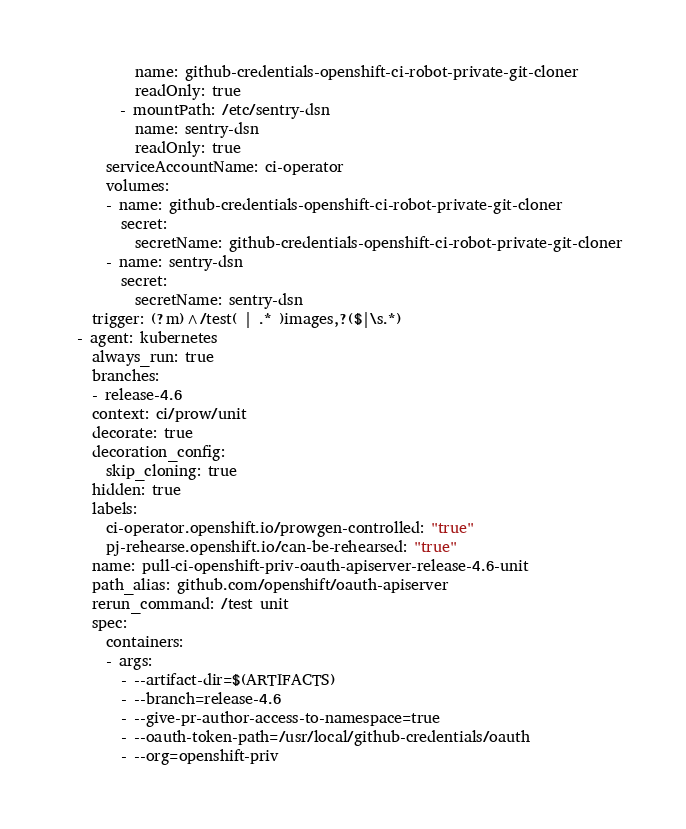<code> <loc_0><loc_0><loc_500><loc_500><_YAML_>          name: github-credentials-openshift-ci-robot-private-git-cloner
          readOnly: true
        - mountPath: /etc/sentry-dsn
          name: sentry-dsn
          readOnly: true
      serviceAccountName: ci-operator
      volumes:
      - name: github-credentials-openshift-ci-robot-private-git-cloner
        secret:
          secretName: github-credentials-openshift-ci-robot-private-git-cloner
      - name: sentry-dsn
        secret:
          secretName: sentry-dsn
    trigger: (?m)^/test( | .* )images,?($|\s.*)
  - agent: kubernetes
    always_run: true
    branches:
    - release-4.6
    context: ci/prow/unit
    decorate: true
    decoration_config:
      skip_cloning: true
    hidden: true
    labels:
      ci-operator.openshift.io/prowgen-controlled: "true"
      pj-rehearse.openshift.io/can-be-rehearsed: "true"
    name: pull-ci-openshift-priv-oauth-apiserver-release-4.6-unit
    path_alias: github.com/openshift/oauth-apiserver
    rerun_command: /test unit
    spec:
      containers:
      - args:
        - --artifact-dir=$(ARTIFACTS)
        - --branch=release-4.6
        - --give-pr-author-access-to-namespace=true
        - --oauth-token-path=/usr/local/github-credentials/oauth
        - --org=openshift-priv</code> 